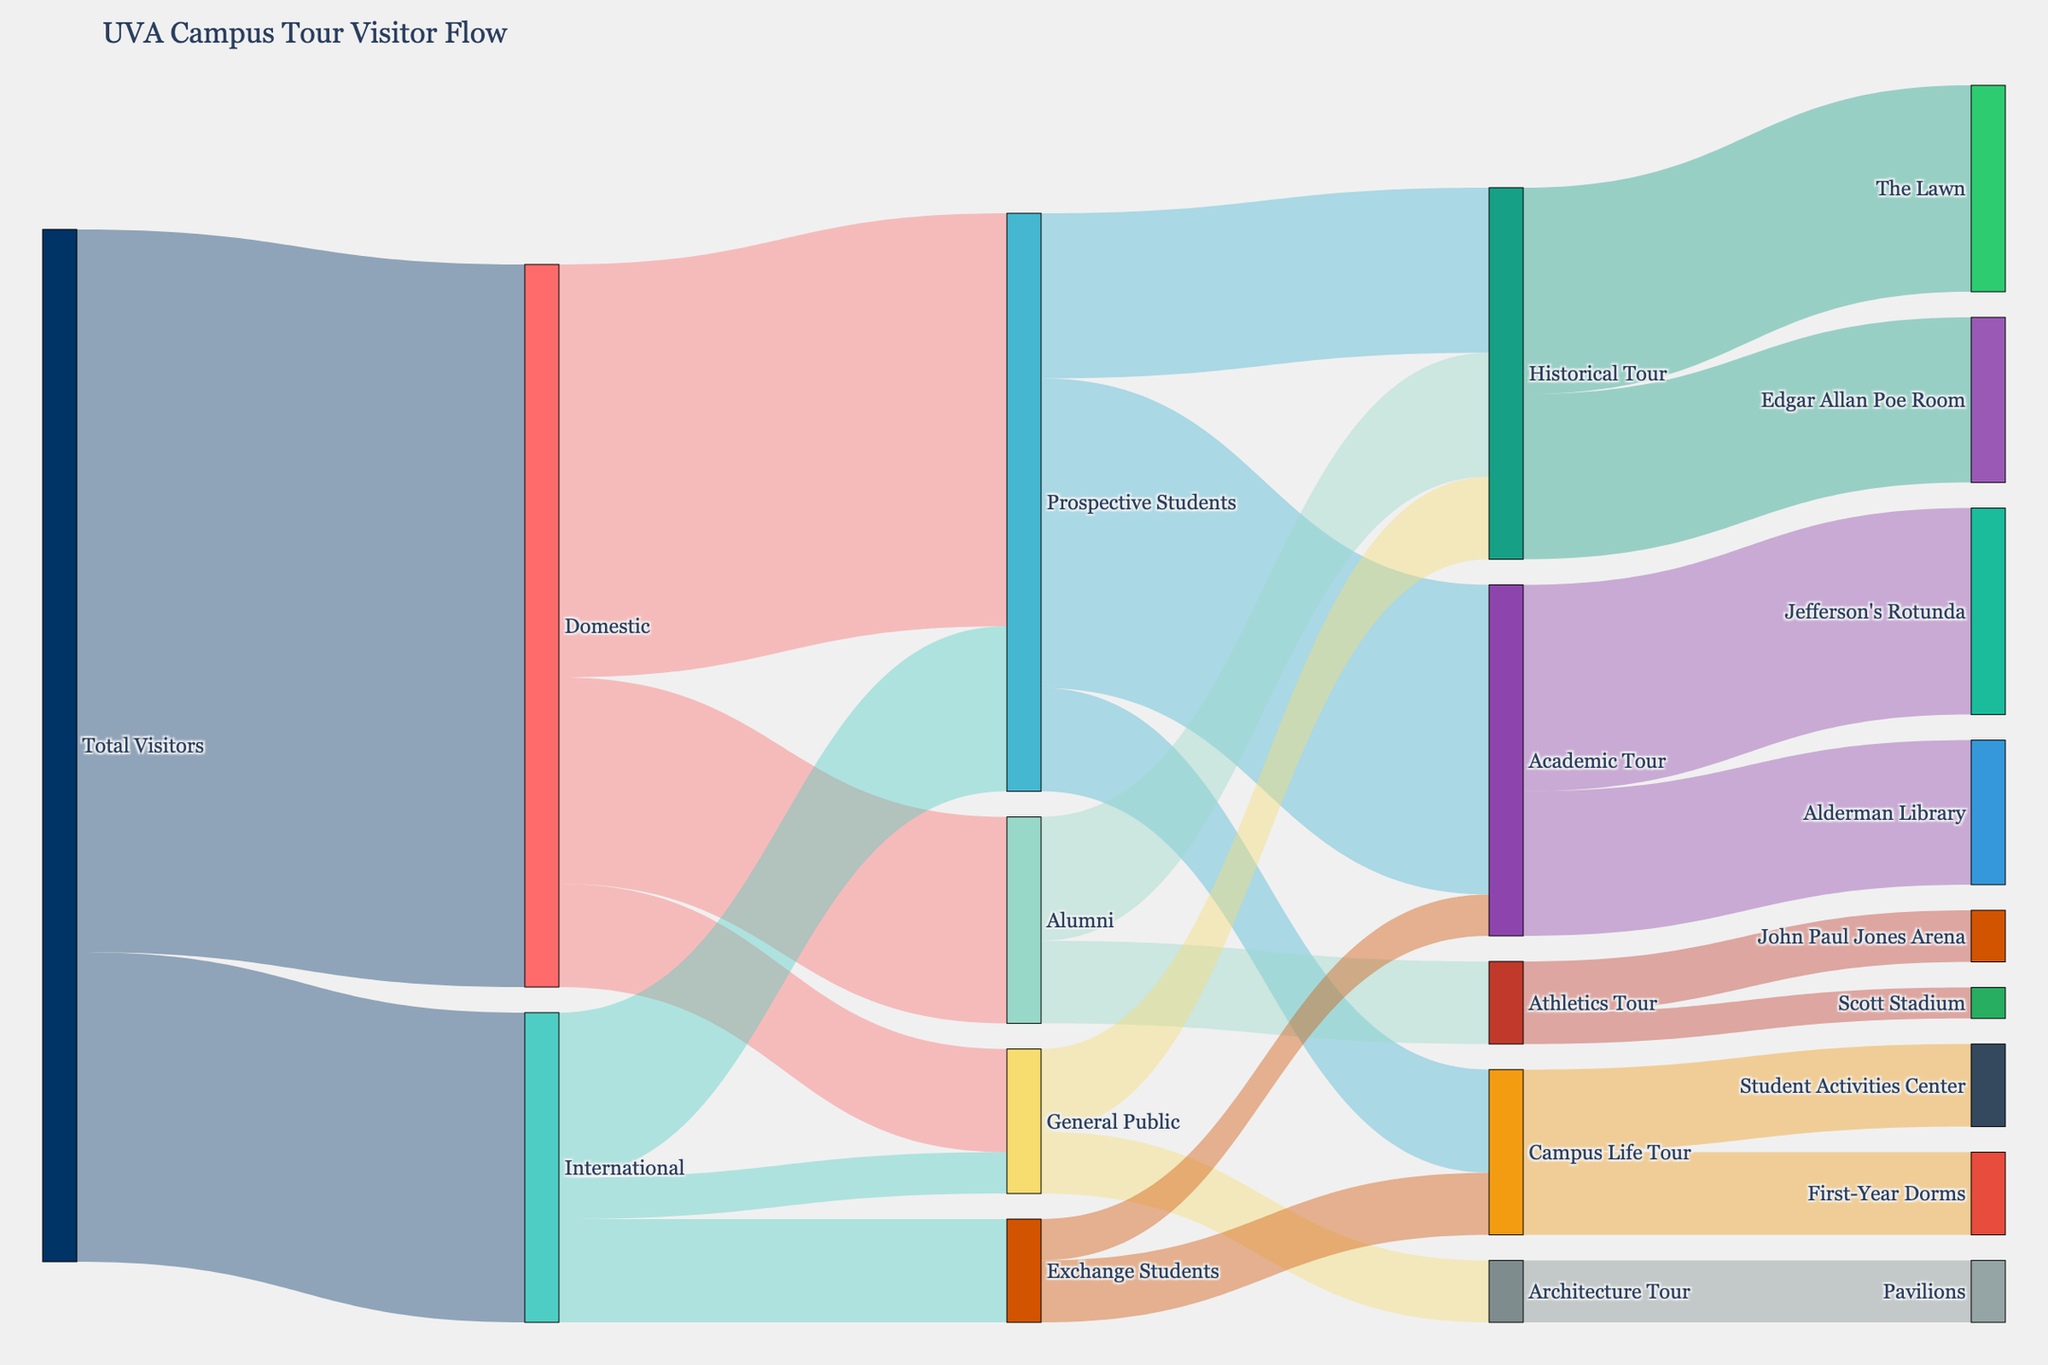what is the primary destination for Domestic visitors? To answer this, look at the paths leading from 'Domestic' and identify the node with the highest value. 'Domestic' has three target nodes: 'Prospective Students' (2000), 'Alumni' (1000), and 'General Public' (500). The highest value is for 'Prospective Students'.
Answer: Prospective Students how many visitors are interested in the Historical Tour? Identify all paths leading to 'Historical Tour'. They are 'Prospective Students' (800), 'Alumni' (600), and 'General Public' (400). Sum the values: 800 + 600 + 400 = 1800.
Answer: 1800 What is the combined number of visitors going on Academic and Historical Tours? Sum the values for paths leading to 'Academic Tour' and 'Historical Tour'. 'Academic Tour' has 1500 ('Prospective Students') and 200 ('Exchange Students'). 'Historical Tour' has 800 ('Prospective Students'), 600 ('Alumni'), and 400 ('General Public'). The total is 1500 + 200 + 800 + 600 + 400 = 3500.
Answer: 3500 Which tour category has more interest from Prospective Students, Academic Tour or Historical Tour? Compare the values of 'Academic Tour' and 'Historical Tour' from the 'Prospective Students' node. 'Academic Tour' has 1500, and 'Historical Tour' has 800.
Answer: Academic Tour What is the most popular campus landmark among Academic Tour visitors? Identify the target nodes connected to 'Academic Tour' and compare their values. They are 'Jefferson's Rotunda' (1000) and 'Alderman Library' (700).
Answer: Jefferson's Rotunda 